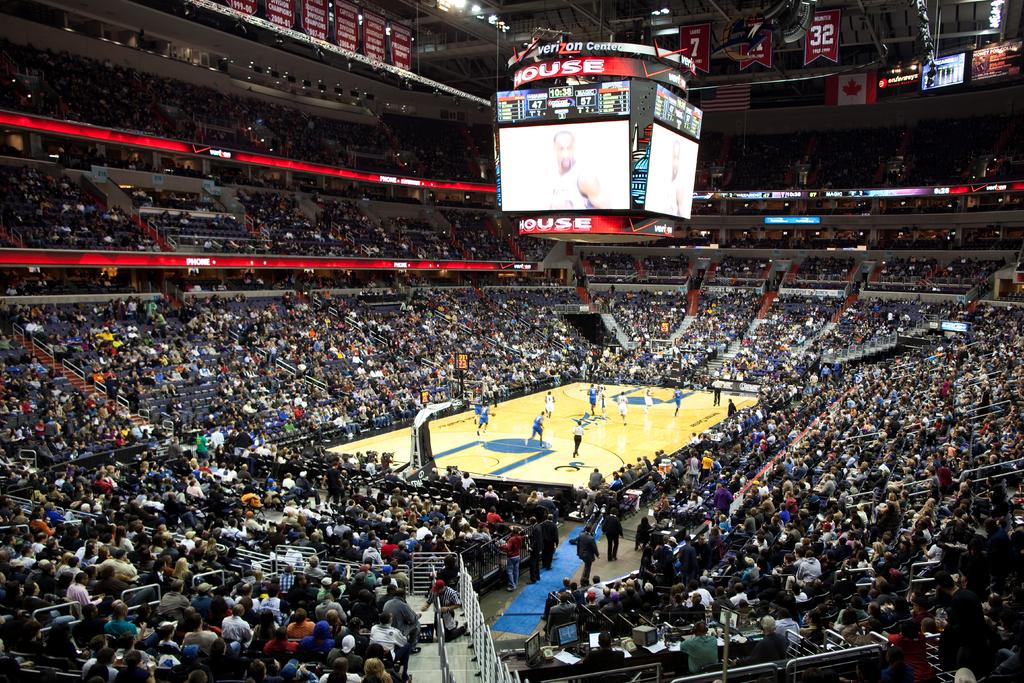What is the current high score on the scoreboard?
Ensure brevity in your answer.  57. What is the brand advertised at the top of the scoreboard?
Provide a short and direct response. Verizon. 